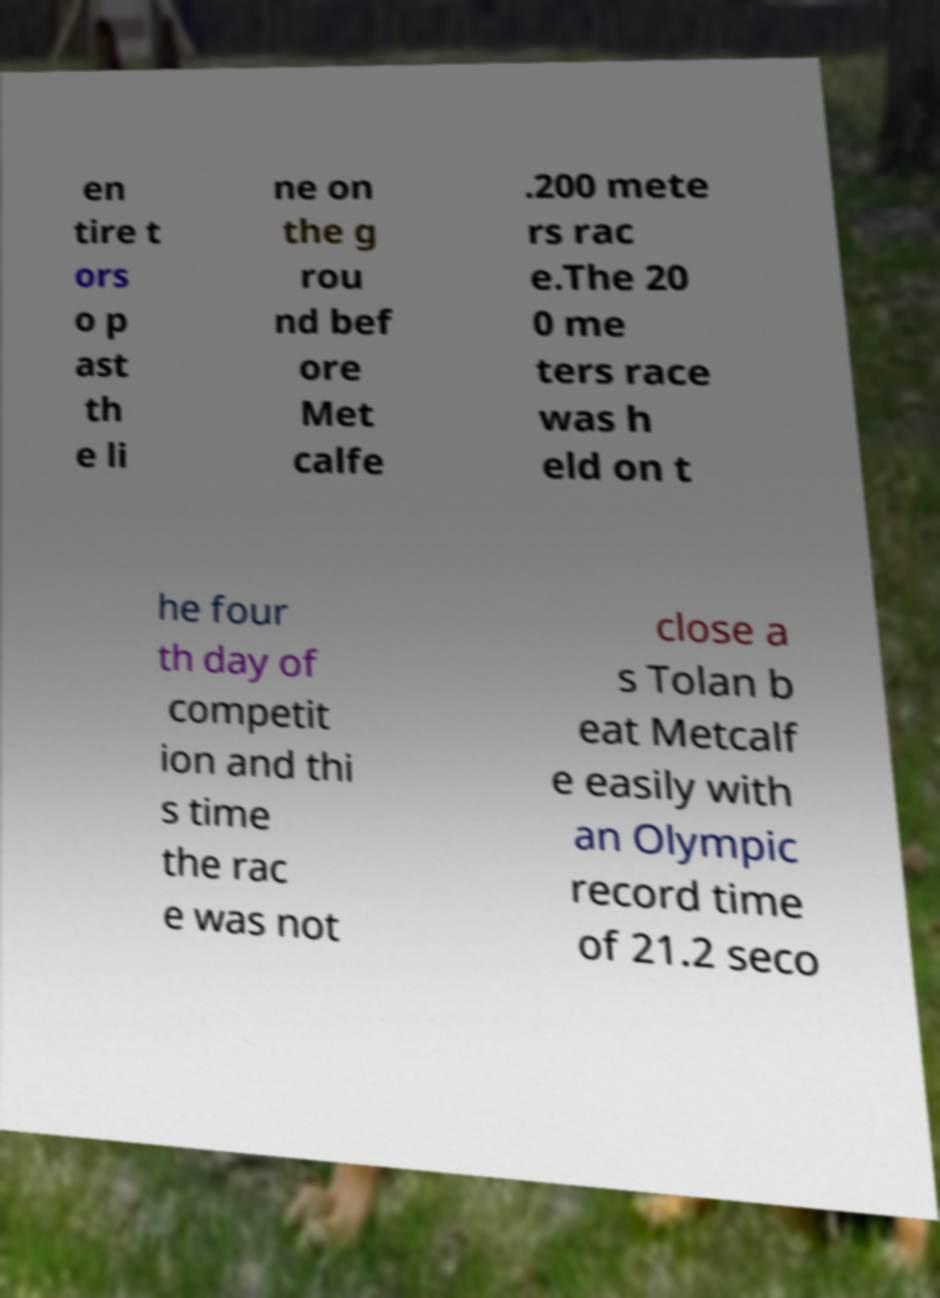Please read and relay the text visible in this image. What does it say? en tire t ors o p ast th e li ne on the g rou nd bef ore Met calfe .200 mete rs rac e.The 20 0 me ters race was h eld on t he four th day of competit ion and thi s time the rac e was not close a s Tolan b eat Metcalf e easily with an Olympic record time of 21.2 seco 